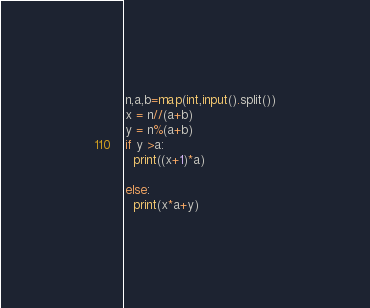Convert code to text. <code><loc_0><loc_0><loc_500><loc_500><_Python_>n,a,b=map(int,input().split())
x = n//(a+b)
y = n%(a+b)
if y >a:
  print((x+1)*a)
 
else:
  print(x*a+y)</code> 